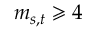<formula> <loc_0><loc_0><loc_500><loc_500>m _ { s , t } \geqslant 4</formula> 